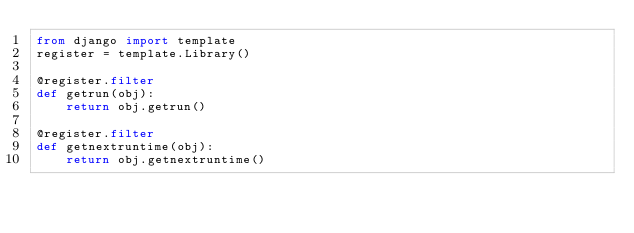<code> <loc_0><loc_0><loc_500><loc_500><_Python_>from django import template
register = template.Library()

@register.filter
def getrun(obj):
    return obj.getrun()

@register.filter
def getnextruntime(obj):
    return obj.getnextruntime()
</code> 